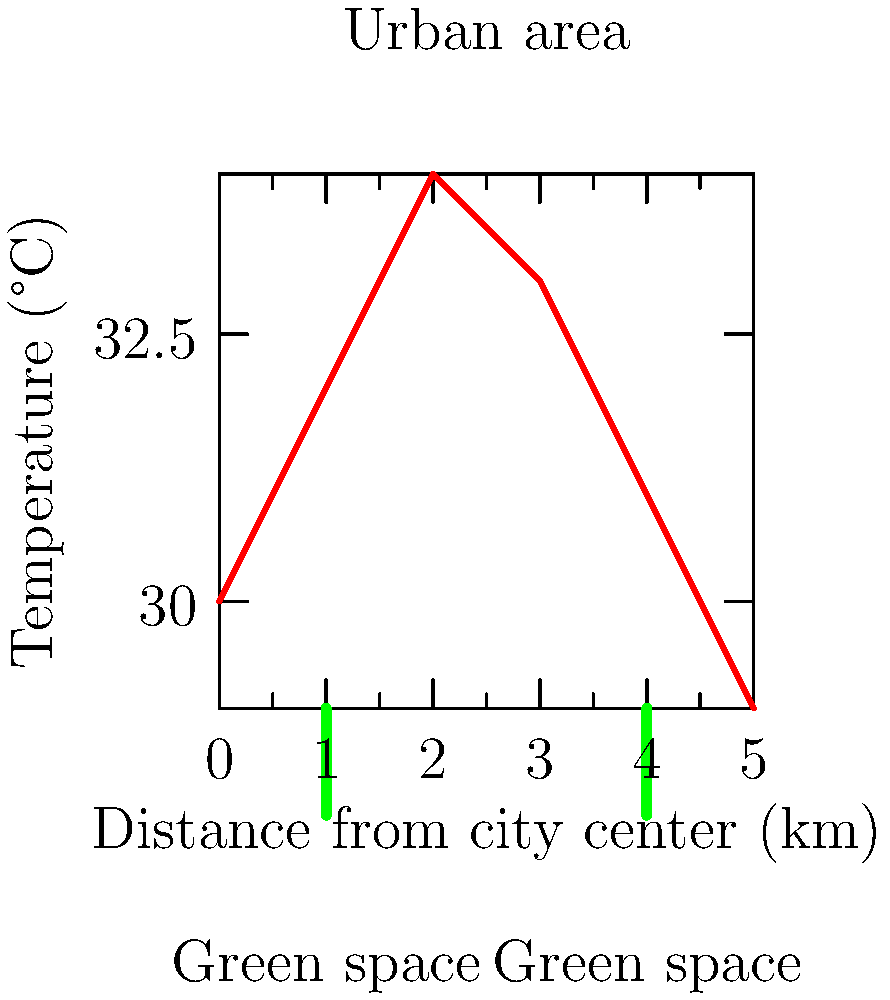The graph shows the temperature distribution across a city, with green spaces indicated. What is the approximate temperature difference between the urban heat island (peak) and the coolest green space? To find the temperature difference between the urban heat island and the coolest green space, we need to:

1. Identify the peak temperature (urban heat island):
   The highest point on the graph is at approximately 34°C.

2. Identify the coolest green space:
   There are two green spaces indicated on the graph, at 1 km and 4 km from the city center.
   The green space at 4 km has a lower temperature, around 31°C.

3. Calculate the difference:
   Temperature difference = Peak temperature - Coolest green space temperature
   $$\Delta T = 34°C - 31°C = 3°C$$

Therefore, the approximate temperature difference between the urban heat island and the coolest green space is 3°C.
Answer: 3°C 